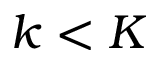<formula> <loc_0><loc_0><loc_500><loc_500>k < K</formula> 